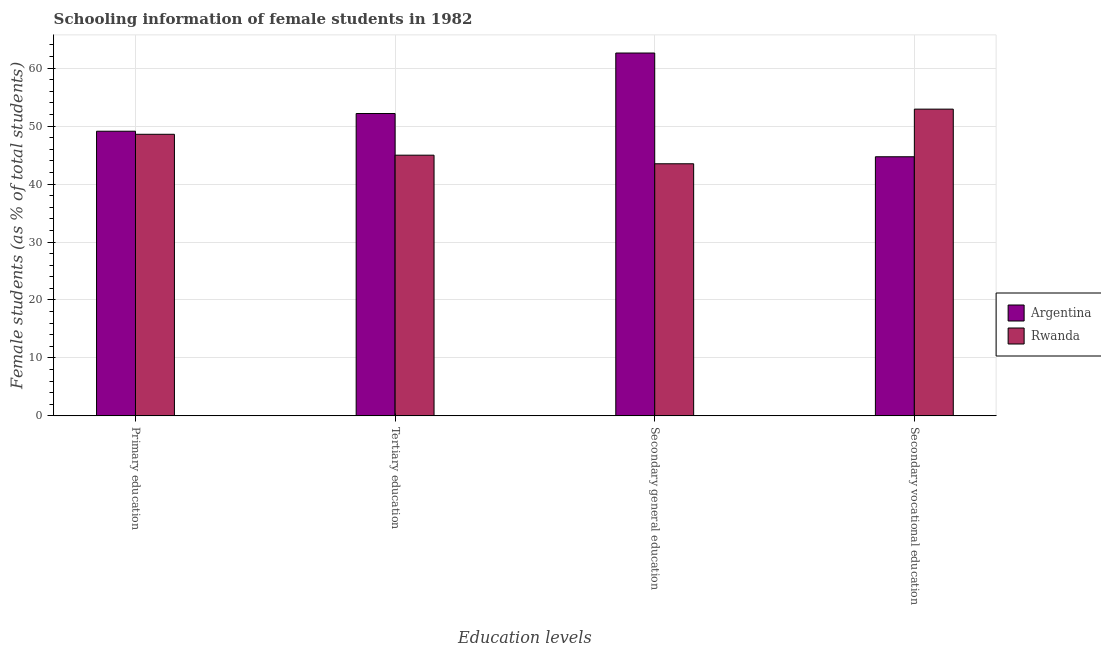How many different coloured bars are there?
Provide a short and direct response. 2. How many groups of bars are there?
Keep it short and to the point. 4. Are the number of bars per tick equal to the number of legend labels?
Give a very brief answer. Yes. How many bars are there on the 2nd tick from the right?
Provide a succinct answer. 2. What is the label of the 4th group of bars from the left?
Your response must be concise. Secondary vocational education. What is the percentage of female students in tertiary education in Argentina?
Your answer should be compact. 52.17. Across all countries, what is the maximum percentage of female students in primary education?
Your answer should be very brief. 49.11. Across all countries, what is the minimum percentage of female students in primary education?
Keep it short and to the point. 48.59. In which country was the percentage of female students in secondary education minimum?
Your answer should be very brief. Rwanda. What is the total percentage of female students in secondary vocational education in the graph?
Ensure brevity in your answer.  97.63. What is the difference between the percentage of female students in primary education in Rwanda and that in Argentina?
Offer a very short reply. -0.53. What is the difference between the percentage of female students in primary education in Argentina and the percentage of female students in secondary education in Rwanda?
Provide a succinct answer. 5.62. What is the average percentage of female students in primary education per country?
Make the answer very short. 48.85. What is the difference between the percentage of female students in primary education and percentage of female students in secondary education in Argentina?
Offer a terse response. -13.49. In how many countries, is the percentage of female students in tertiary education greater than 48 %?
Provide a succinct answer. 1. What is the ratio of the percentage of female students in tertiary education in Argentina to that in Rwanda?
Make the answer very short. 1.16. Is the percentage of female students in tertiary education in Argentina less than that in Rwanda?
Your answer should be very brief. No. Is the difference between the percentage of female students in primary education in Argentina and Rwanda greater than the difference between the percentage of female students in secondary education in Argentina and Rwanda?
Your answer should be very brief. No. What is the difference between the highest and the second highest percentage of female students in secondary vocational education?
Provide a short and direct response. 8.22. What is the difference between the highest and the lowest percentage of female students in secondary education?
Your answer should be compact. 19.11. Is it the case that in every country, the sum of the percentage of female students in secondary vocational education and percentage of female students in primary education is greater than the sum of percentage of female students in secondary education and percentage of female students in tertiary education?
Your answer should be very brief. No. What does the 2nd bar from the left in Secondary vocational education represents?
Your answer should be compact. Rwanda. Are all the bars in the graph horizontal?
Offer a very short reply. No. What is the difference between two consecutive major ticks on the Y-axis?
Your answer should be very brief. 10. Does the graph contain grids?
Give a very brief answer. Yes. How many legend labels are there?
Your answer should be very brief. 2. What is the title of the graph?
Ensure brevity in your answer.  Schooling information of female students in 1982. What is the label or title of the X-axis?
Offer a very short reply. Education levels. What is the label or title of the Y-axis?
Your response must be concise. Female students (as % of total students). What is the Female students (as % of total students) in Argentina in Primary education?
Keep it short and to the point. 49.11. What is the Female students (as % of total students) of Rwanda in Primary education?
Your answer should be very brief. 48.59. What is the Female students (as % of total students) of Argentina in Tertiary education?
Offer a very short reply. 52.17. What is the Female students (as % of total students) in Rwanda in Tertiary education?
Make the answer very short. 44.98. What is the Female students (as % of total students) in Argentina in Secondary general education?
Offer a very short reply. 62.61. What is the Female students (as % of total students) in Rwanda in Secondary general education?
Keep it short and to the point. 43.5. What is the Female students (as % of total students) of Argentina in Secondary vocational education?
Your response must be concise. 44.71. What is the Female students (as % of total students) in Rwanda in Secondary vocational education?
Offer a terse response. 52.93. Across all Education levels, what is the maximum Female students (as % of total students) in Argentina?
Keep it short and to the point. 62.61. Across all Education levels, what is the maximum Female students (as % of total students) in Rwanda?
Offer a very short reply. 52.93. Across all Education levels, what is the minimum Female students (as % of total students) in Argentina?
Your answer should be compact. 44.71. Across all Education levels, what is the minimum Female students (as % of total students) of Rwanda?
Keep it short and to the point. 43.5. What is the total Female students (as % of total students) of Argentina in the graph?
Offer a very short reply. 208.6. What is the total Female students (as % of total students) in Rwanda in the graph?
Your answer should be compact. 189.99. What is the difference between the Female students (as % of total students) in Argentina in Primary education and that in Tertiary education?
Your answer should be compact. -3.05. What is the difference between the Female students (as % of total students) in Rwanda in Primary education and that in Tertiary education?
Give a very brief answer. 3.61. What is the difference between the Female students (as % of total students) in Argentina in Primary education and that in Secondary general education?
Keep it short and to the point. -13.49. What is the difference between the Female students (as % of total students) in Rwanda in Primary education and that in Secondary general education?
Your answer should be very brief. 5.09. What is the difference between the Female students (as % of total students) of Argentina in Primary education and that in Secondary vocational education?
Your response must be concise. 4.41. What is the difference between the Female students (as % of total students) in Rwanda in Primary education and that in Secondary vocational education?
Ensure brevity in your answer.  -4.34. What is the difference between the Female students (as % of total students) in Argentina in Tertiary education and that in Secondary general education?
Your answer should be compact. -10.44. What is the difference between the Female students (as % of total students) in Rwanda in Tertiary education and that in Secondary general education?
Give a very brief answer. 1.48. What is the difference between the Female students (as % of total students) in Argentina in Tertiary education and that in Secondary vocational education?
Offer a terse response. 7.46. What is the difference between the Female students (as % of total students) in Rwanda in Tertiary education and that in Secondary vocational education?
Make the answer very short. -7.95. What is the difference between the Female students (as % of total students) of Argentina in Secondary general education and that in Secondary vocational education?
Your answer should be very brief. 17.9. What is the difference between the Female students (as % of total students) of Rwanda in Secondary general education and that in Secondary vocational education?
Provide a short and direct response. -9.43. What is the difference between the Female students (as % of total students) of Argentina in Primary education and the Female students (as % of total students) of Rwanda in Tertiary education?
Make the answer very short. 4.13. What is the difference between the Female students (as % of total students) of Argentina in Primary education and the Female students (as % of total students) of Rwanda in Secondary general education?
Give a very brief answer. 5.62. What is the difference between the Female students (as % of total students) of Argentina in Primary education and the Female students (as % of total students) of Rwanda in Secondary vocational education?
Keep it short and to the point. -3.81. What is the difference between the Female students (as % of total students) in Argentina in Tertiary education and the Female students (as % of total students) in Rwanda in Secondary general education?
Your response must be concise. 8.67. What is the difference between the Female students (as % of total students) of Argentina in Tertiary education and the Female students (as % of total students) of Rwanda in Secondary vocational education?
Make the answer very short. -0.76. What is the difference between the Female students (as % of total students) in Argentina in Secondary general education and the Female students (as % of total students) in Rwanda in Secondary vocational education?
Make the answer very short. 9.68. What is the average Female students (as % of total students) of Argentina per Education levels?
Your answer should be compact. 52.15. What is the average Female students (as % of total students) of Rwanda per Education levels?
Provide a short and direct response. 47.5. What is the difference between the Female students (as % of total students) of Argentina and Female students (as % of total students) of Rwanda in Primary education?
Give a very brief answer. 0.53. What is the difference between the Female students (as % of total students) of Argentina and Female students (as % of total students) of Rwanda in Tertiary education?
Provide a succinct answer. 7.19. What is the difference between the Female students (as % of total students) in Argentina and Female students (as % of total students) in Rwanda in Secondary general education?
Ensure brevity in your answer.  19.11. What is the difference between the Female students (as % of total students) of Argentina and Female students (as % of total students) of Rwanda in Secondary vocational education?
Offer a terse response. -8.22. What is the ratio of the Female students (as % of total students) in Argentina in Primary education to that in Tertiary education?
Offer a very short reply. 0.94. What is the ratio of the Female students (as % of total students) in Rwanda in Primary education to that in Tertiary education?
Keep it short and to the point. 1.08. What is the ratio of the Female students (as % of total students) of Argentina in Primary education to that in Secondary general education?
Your answer should be very brief. 0.78. What is the ratio of the Female students (as % of total students) of Rwanda in Primary education to that in Secondary general education?
Keep it short and to the point. 1.12. What is the ratio of the Female students (as % of total students) in Argentina in Primary education to that in Secondary vocational education?
Your answer should be compact. 1.1. What is the ratio of the Female students (as % of total students) of Rwanda in Primary education to that in Secondary vocational education?
Your answer should be compact. 0.92. What is the ratio of the Female students (as % of total students) in Rwanda in Tertiary education to that in Secondary general education?
Offer a terse response. 1.03. What is the ratio of the Female students (as % of total students) in Argentina in Tertiary education to that in Secondary vocational education?
Give a very brief answer. 1.17. What is the ratio of the Female students (as % of total students) of Rwanda in Tertiary education to that in Secondary vocational education?
Offer a very short reply. 0.85. What is the ratio of the Female students (as % of total students) of Argentina in Secondary general education to that in Secondary vocational education?
Offer a terse response. 1.4. What is the ratio of the Female students (as % of total students) of Rwanda in Secondary general education to that in Secondary vocational education?
Your response must be concise. 0.82. What is the difference between the highest and the second highest Female students (as % of total students) in Argentina?
Offer a very short reply. 10.44. What is the difference between the highest and the second highest Female students (as % of total students) in Rwanda?
Ensure brevity in your answer.  4.34. What is the difference between the highest and the lowest Female students (as % of total students) in Argentina?
Ensure brevity in your answer.  17.9. What is the difference between the highest and the lowest Female students (as % of total students) in Rwanda?
Your answer should be compact. 9.43. 